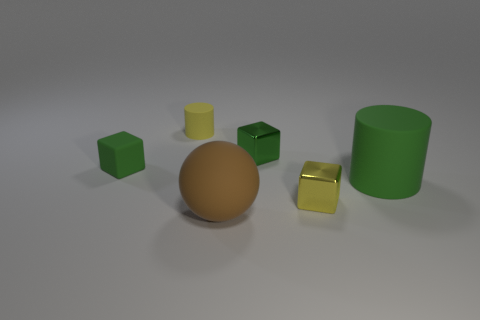Is there anything else that has the same shape as the big brown object?
Your answer should be very brief. No. Do the green rubber cylinder and the green metallic cube have the same size?
Give a very brief answer. No. There is a tiny cylinder; is it the same color as the big rubber thing that is on the right side of the big brown rubber object?
Provide a succinct answer. No. What shape is the tiny green thing that is made of the same material as the big green cylinder?
Provide a succinct answer. Cube. There is a small yellow thing that is in front of the small rubber cube; is it the same shape as the large green object?
Offer a terse response. No. There is a matte cylinder right of the metal block in front of the green matte cylinder; what size is it?
Your answer should be compact. Large. The other cube that is made of the same material as the yellow block is what color?
Your answer should be compact. Green. How many green matte things have the same size as the brown matte object?
Your answer should be compact. 1. How many yellow objects are either large matte blocks or small metallic objects?
Make the answer very short. 1. What number of things are either tiny green metal cubes or green cubes that are on the left side of the small matte cylinder?
Give a very brief answer. 2. 